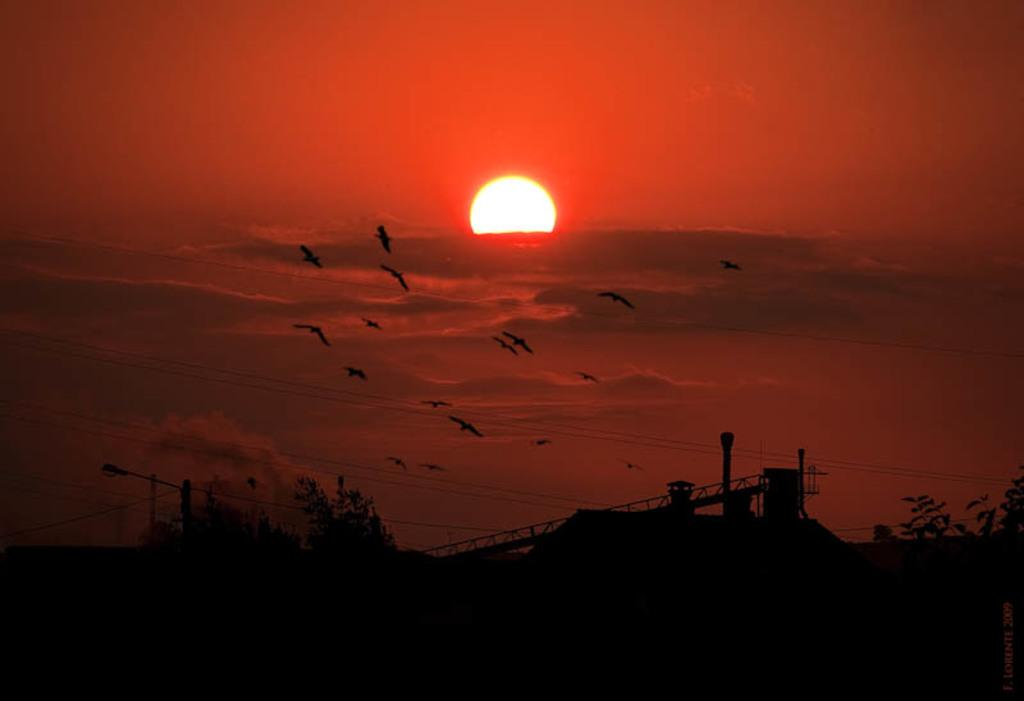What is the main feature of the image? There is a beautiful view of a sunset in the image. What can be seen in the sky during the sunset? Birds are flying in the sky in the image. What type of vegetation is present in the image? There are trees in the image. Are there any structures or objects between the trees? Yes, there are poles in between the trees in the image. Can you see a thumb holding a cabbage in the image? No, there is no thumb or cabbage present in the image. How many hens are visible in the image? There are no hens visible in the image. 